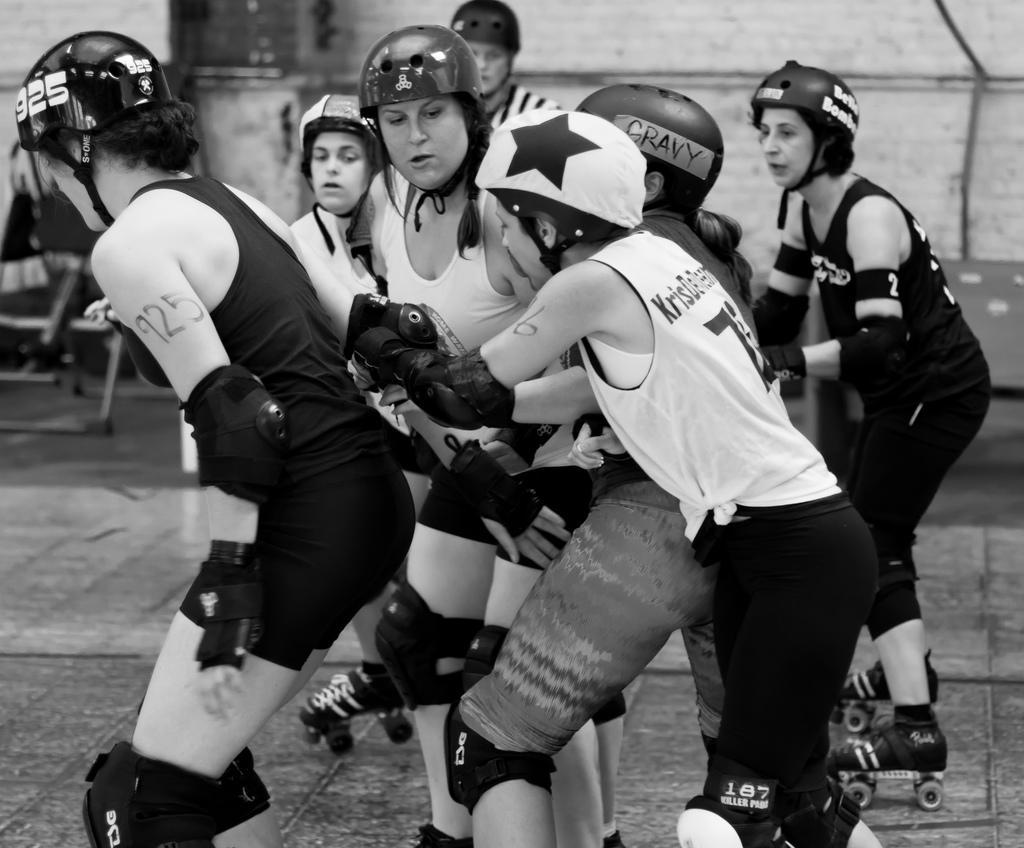Please provide a concise description of this image. This is a black and white image where we can see many women wearing T-shirts, gloves and helmets are standing here. The background of the image is slightly blurred, where we can see another person, some objects and I can see the wall. 